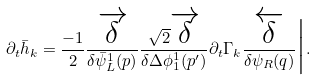<formula> <loc_0><loc_0><loc_500><loc_500>\partial _ { t } \bar { h } _ { k } = \frac { - 1 } { 2 } \frac { \overrightarrow { \delta } } { \delta \bar { \psi } _ { L } ^ { 1 } ( p ) } \frac { \sqrt { 2 } \overrightarrow { \delta } } { \delta \Delta \phi _ { 1 } ^ { 1 } ( p ^ { \prime } ) } \partial _ { t } \Gamma _ { k } \frac { \overleftarrow { \delta } } { \delta \psi _ { R } ( q ) } \Big | .</formula> 